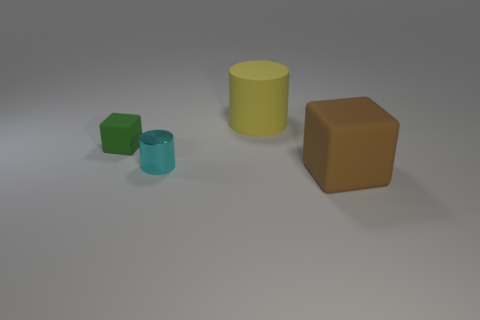What is the material of the other object that is the same shape as the small shiny object?
Provide a short and direct response. Rubber. What shape is the rubber thing that is right of the cyan metal cylinder and left of the big rubber block?
Provide a succinct answer. Cylinder. What is the shape of the small green object that is made of the same material as the large cylinder?
Your answer should be compact. Cube. There is a cylinder to the left of the big yellow matte object; what is its material?
Ensure brevity in your answer.  Metal. There is a matte thing that is in front of the green matte object; is it the same size as the cylinder that is in front of the yellow matte object?
Provide a short and direct response. No. What is the color of the small shiny thing?
Offer a terse response. Cyan. Do the big object behind the brown block and the cyan shiny thing have the same shape?
Give a very brief answer. Yes. What is the large cylinder made of?
Offer a terse response. Rubber. What shape is the other object that is the same size as the brown object?
Provide a succinct answer. Cylinder. What color is the big matte thing that is left of the big object that is in front of the tiny rubber cube?
Offer a terse response. Yellow. 